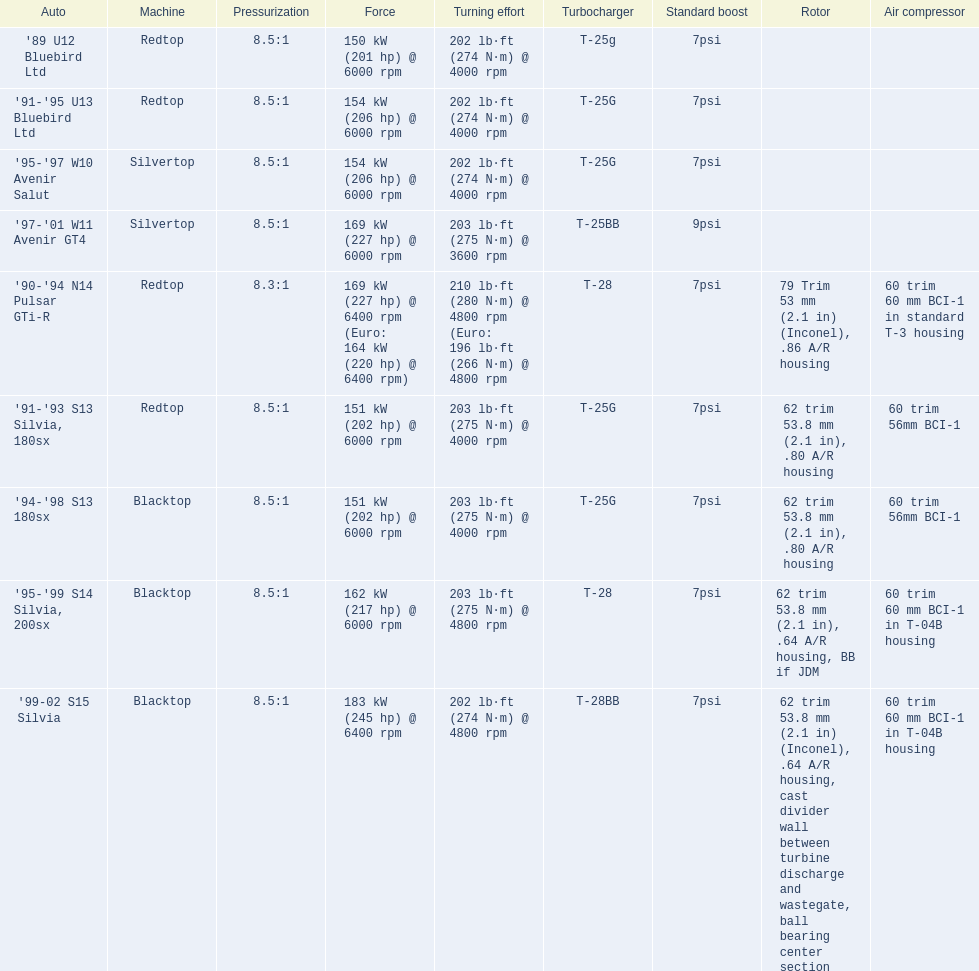Can you give me this table as a dict? {'header': ['Auto', 'Machine', 'Pressurization', 'Force', 'Turning effort', 'Turbocharger', 'Standard boost', 'Rotor', 'Air compressor'], 'rows': [["'89 U12 Bluebird Ltd", 'Redtop', '8.5:1', '150\xa0kW (201\xa0hp) @ 6000 rpm', '202\xa0lb·ft (274\xa0N·m) @ 4000 rpm', 'T-25g', '7psi', '', ''], ["'91-'95 U13 Bluebird Ltd", 'Redtop', '8.5:1', '154\xa0kW (206\xa0hp) @ 6000 rpm', '202\xa0lb·ft (274\xa0N·m) @ 4000 rpm', 'T-25G', '7psi', '', ''], ["'95-'97 W10 Avenir Salut", 'Silvertop', '8.5:1', '154\xa0kW (206\xa0hp) @ 6000 rpm', '202\xa0lb·ft (274\xa0N·m) @ 4000 rpm', 'T-25G', '7psi', '', ''], ["'97-'01 W11 Avenir GT4", 'Silvertop', '8.5:1', '169\xa0kW (227\xa0hp) @ 6000 rpm', '203\xa0lb·ft (275\xa0N·m) @ 3600 rpm', 'T-25BB', '9psi', '', ''], ["'90-'94 N14 Pulsar GTi-R", 'Redtop', '8.3:1', '169\xa0kW (227\xa0hp) @ 6400 rpm (Euro: 164\xa0kW (220\xa0hp) @ 6400 rpm)', '210\xa0lb·ft (280\xa0N·m) @ 4800 rpm (Euro: 196\xa0lb·ft (266\xa0N·m) @ 4800 rpm', 'T-28', '7psi', '79 Trim 53\xa0mm (2.1\xa0in) (Inconel), .86 A/R housing', '60 trim 60\xa0mm BCI-1 in standard T-3 housing'], ["'91-'93 S13 Silvia, 180sx", 'Redtop', '8.5:1', '151\xa0kW (202\xa0hp) @ 6000 rpm', '203\xa0lb·ft (275\xa0N·m) @ 4000 rpm', 'T-25G', '7psi', '62 trim 53.8\xa0mm (2.1\xa0in), .80 A/R housing', '60 trim 56mm BCI-1'], ["'94-'98 S13 180sx", 'Blacktop', '8.5:1', '151\xa0kW (202\xa0hp) @ 6000 rpm', '203\xa0lb·ft (275\xa0N·m) @ 4000 rpm', 'T-25G', '7psi', '62 trim 53.8\xa0mm (2.1\xa0in), .80 A/R housing', '60 trim 56mm BCI-1'], ["'95-'99 S14 Silvia, 200sx", 'Blacktop', '8.5:1', '162\xa0kW (217\xa0hp) @ 6000 rpm', '203\xa0lb·ft (275\xa0N·m) @ 4800 rpm', 'T-28', '7psi', '62 trim 53.8\xa0mm (2.1\xa0in), .64 A/R housing, BB if JDM', '60 trim 60\xa0mm BCI-1 in T-04B housing'], ["'99-02 S15 Silvia", 'Blacktop', '8.5:1', '183\xa0kW (245\xa0hp) @ 6400 rpm', '202\xa0lb·ft (274\xa0N·m) @ 4800 rpm', 'T-28BB', '7psi', '62 trim 53.8\xa0mm (2.1\xa0in) (Inconel), .64 A/R housing, cast divider wall between turbine discharge and wastegate, ball bearing center section', '60 trim 60\xa0mm BCI-1 in T-04B housing']]} Which car's power measured at higher than 6000 rpm? '90-'94 N14 Pulsar GTi-R, '99-02 S15 Silvia. 